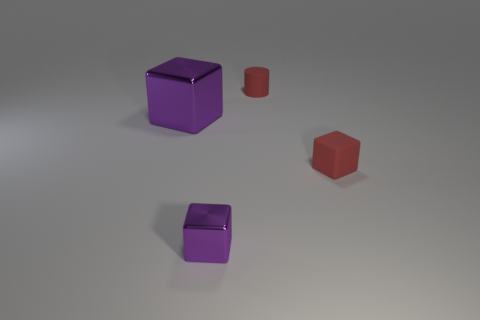What size is the object that is the same color as the small rubber cylinder?
Keep it short and to the point. Small. What is the color of the object that is both to the right of the tiny purple metal object and in front of the small red cylinder?
Your answer should be compact. Red. What is the color of the small object that is on the right side of the red cylinder?
Keep it short and to the point. Red. Is there a purple object of the same size as the red cylinder?
Ensure brevity in your answer.  Yes. What is the material of the red block that is the same size as the red matte cylinder?
Make the answer very short. Rubber. How many objects are cubes left of the red cylinder or purple cubes in front of the large purple cube?
Ensure brevity in your answer.  2. Are there any other big purple metal objects of the same shape as the large purple object?
Give a very brief answer. No. There is a tiny cube that is the same color as the large metallic block; what material is it?
Offer a very short reply. Metal. What number of shiny things are either purple cubes or big purple blocks?
Offer a terse response. 2. What shape is the big metal object?
Keep it short and to the point. Cube. 